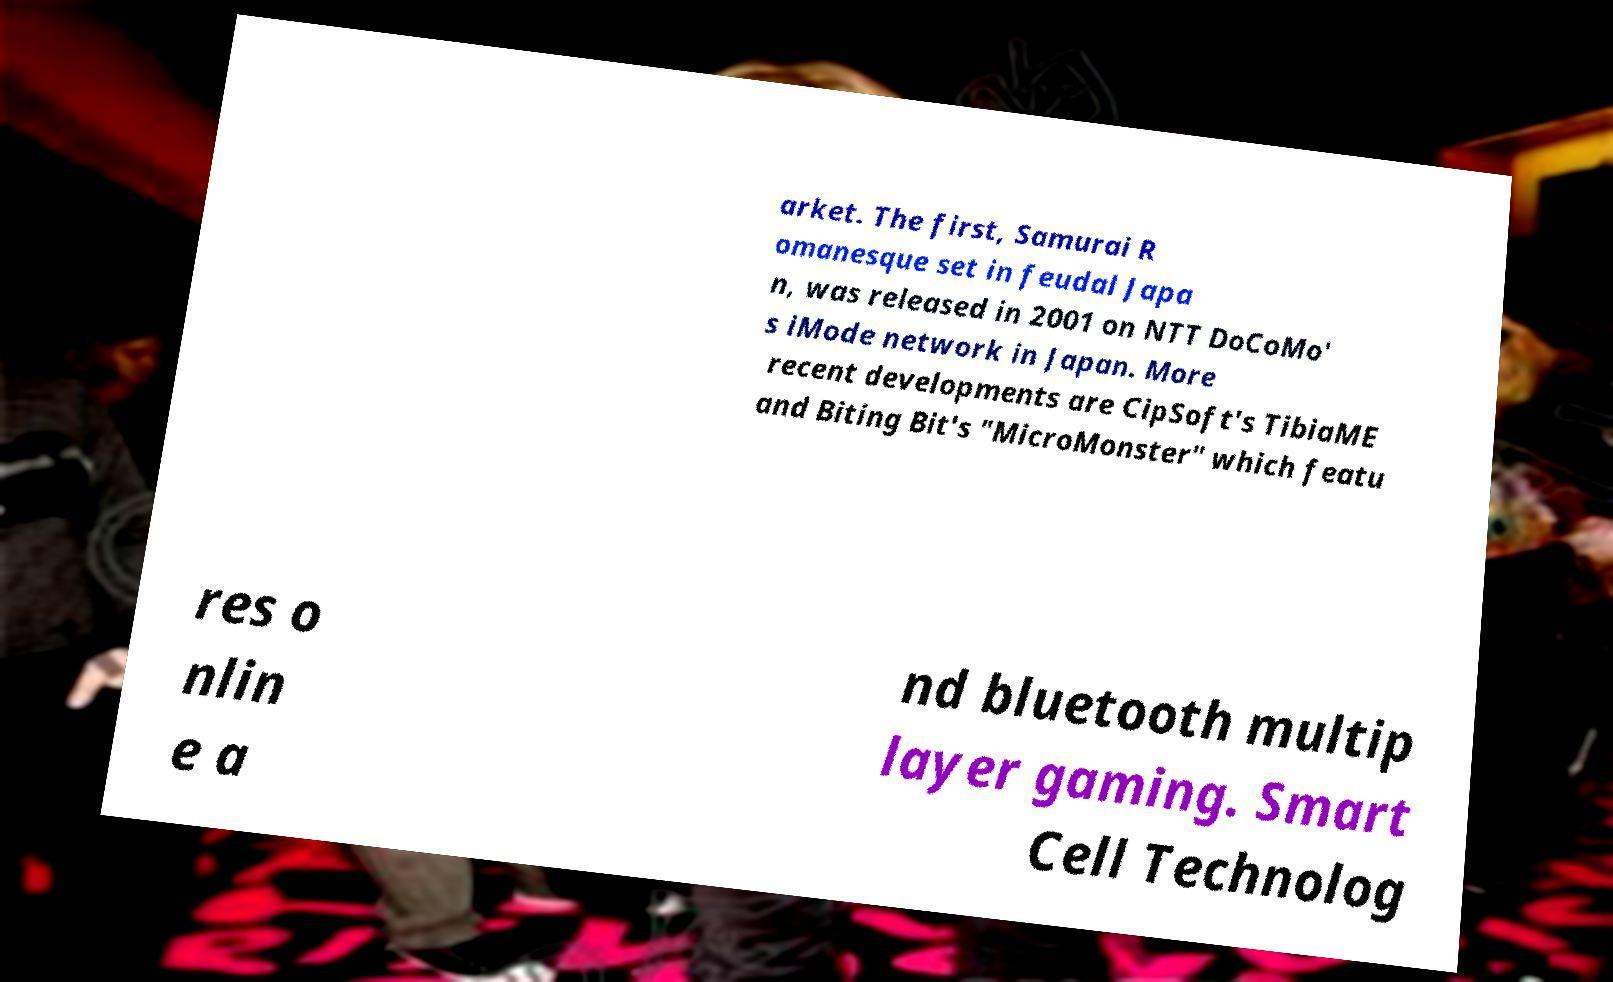Please identify and transcribe the text found in this image. arket. The first, Samurai R omanesque set in feudal Japa n, was released in 2001 on NTT DoCoMo' s iMode network in Japan. More recent developments are CipSoft's TibiaME and Biting Bit's "MicroMonster" which featu res o nlin e a nd bluetooth multip layer gaming. Smart Cell Technolog 